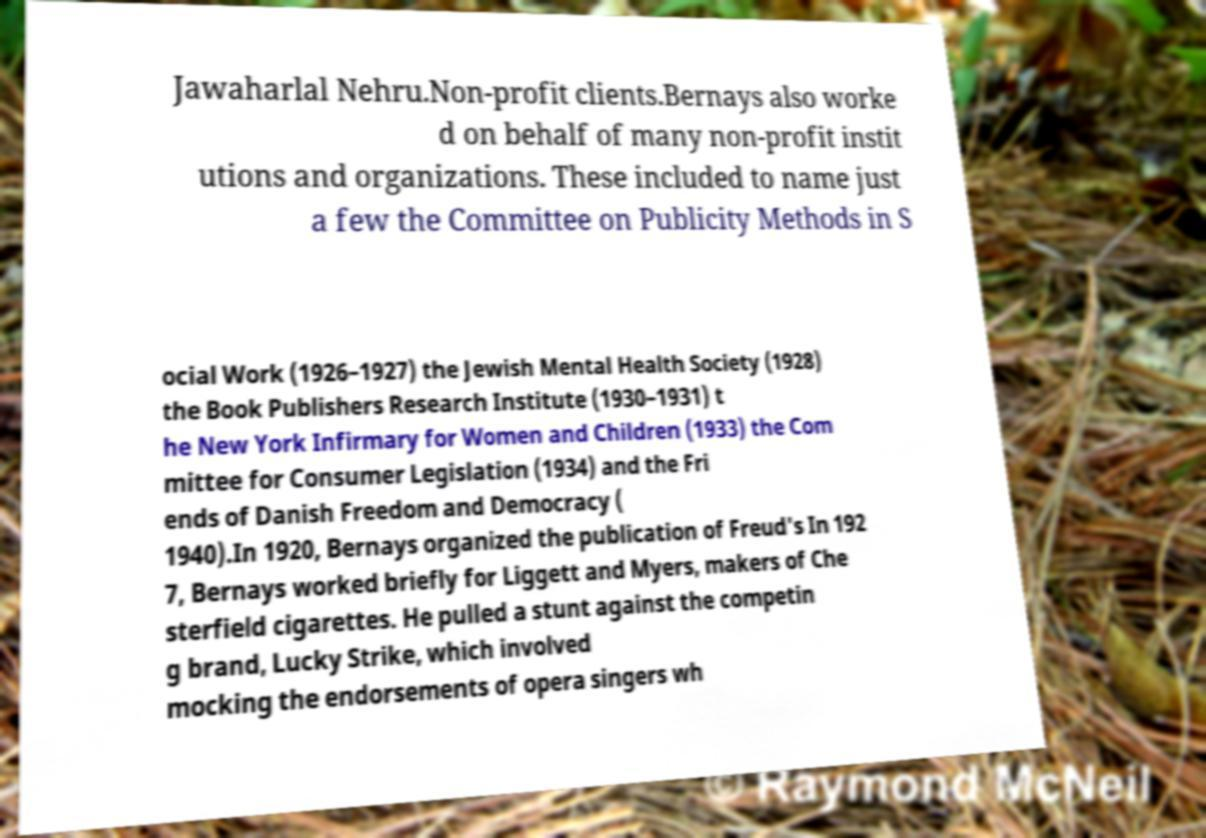Please read and relay the text visible in this image. What does it say? Jawaharlal Nehru.Non-profit clients.Bernays also worke d on behalf of many non-profit instit utions and organizations. These included to name just a few the Committee on Publicity Methods in S ocial Work (1926–1927) the Jewish Mental Health Society (1928) the Book Publishers Research Institute (1930–1931) t he New York Infirmary for Women and Children (1933) the Com mittee for Consumer Legislation (1934) and the Fri ends of Danish Freedom and Democracy ( 1940).In 1920, Bernays organized the publication of Freud's In 192 7, Bernays worked briefly for Liggett and Myers, makers of Che sterfield cigarettes. He pulled a stunt against the competin g brand, Lucky Strike, which involved mocking the endorsements of opera singers wh 